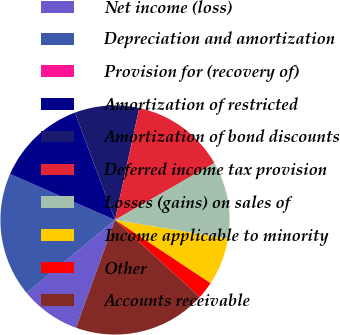<chart> <loc_0><loc_0><loc_500><loc_500><pie_chart><fcel>Net income (loss)<fcel>Depreciation and amortization<fcel>Provision for (recovery of)<fcel>Amortization of restricted<fcel>Amortization of bond discounts<fcel>Deferred income tax provision<fcel>Losses (gains) on sales of<fcel>Income applicable to minority<fcel>Other<fcel>Accounts receivable<nl><fcel>8.49%<fcel>17.57%<fcel>0.0%<fcel>12.73%<fcel>9.09%<fcel>13.33%<fcel>10.91%<fcel>6.67%<fcel>2.43%<fcel>18.78%<nl></chart> 